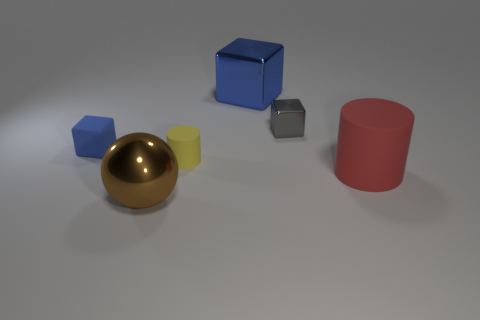Can you describe the lighting in the scene? The scene is lit from above, resulting in soft shadows directly under and to the side of each object, suggesting diffused or indirect natural light, which creates a calm and even setting without harsh contrasts. 